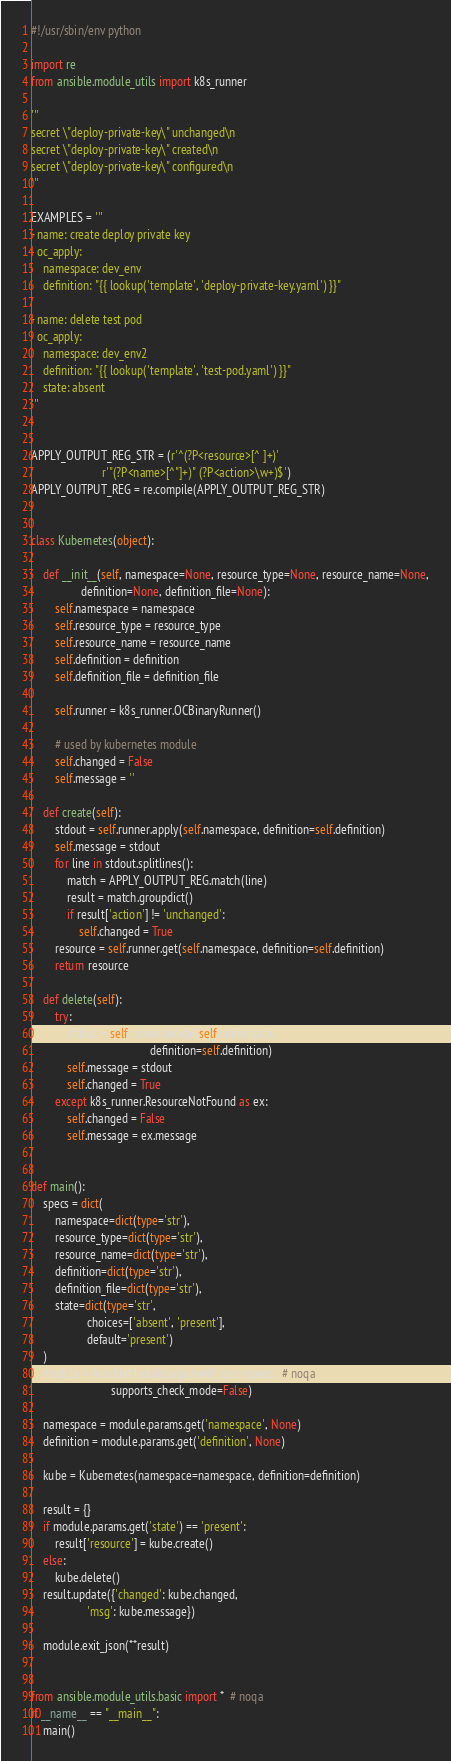Convert code to text. <code><loc_0><loc_0><loc_500><loc_500><_Python_>#!/usr/sbin/env python

import re
from ansible.module_utils import k8s_runner

'''
secret \"deploy-private-key\" unchanged\n
secret \"deploy-private-key\" created\n
secret \"deploy-private-key\" configured\n
'''

EXAMPLES = '''
- name: create deploy private key
  oc_apply:
    namespace: dev_env
    definition: "{{ lookup('template', 'deploy-private-key.yaml') }}"

- name: delete test pod
  oc_apply:
    namespace: dev_env2
    definition: "{{ lookup('template', 'test-pod.yaml') }}"
    state: absent
'''


APPLY_OUTPUT_REG_STR = (r'^(?P<resource>[^ ]+)'
                        r'"(?P<name>[^"]+)" (?P<action>\w+)$')
APPLY_OUTPUT_REG = re.compile(APPLY_OUTPUT_REG_STR)


class Kubernetes(object):

    def __init__(self, namespace=None, resource_type=None, resource_name=None,
                 definition=None, definition_file=None):
        self.namespace = namespace
        self.resource_type = resource_type
        self.resource_name = resource_name
        self.definition = definition
        self.definition_file = definition_file

        self.runner = k8s_runner.OCBinaryRunner()

        # used by kubernetes module
        self.changed = False
        self.message = ''

    def create(self):
        stdout = self.runner.apply(self.namespace, definition=self.definition)
        self.message = stdout
        for line in stdout.splitlines():
            match = APPLY_OUTPUT_REG.match(line)
            result = match.groupdict()
            if result['action'] != 'unchanged':
                self.changed = True
        resource = self.runner.get(self.namespace, definition=self.definition)
        return resource

    def delete(self):
        try:
            stdout = self.runner.delete(self.namespace,
                                        definition=self.definition)
            self.message = stdout
            self.changed = True
        except k8s_runner.ResourceNotFound as ex:
            self.changed = False
            self.message = ex.message


def main():
    specs = dict(
        namespace=dict(type='str'),
        resource_type=dict(type='str'),
        resource_name=dict(type='str'),
        definition=dict(type='str'),
        definition_file=dict(type='str'),
        state=dict(type='str',
                   choices=['absent', 'present'],
                   default='present')
    )
    module = AnsibleModule(argument_spec=specs,  # noqa
                           supports_check_mode=False)

    namespace = module.params.get('namespace', None)
    definition = module.params.get('definition', None)

    kube = Kubernetes(namespace=namespace, definition=definition)

    result = {}
    if module.params.get('state') == 'present':
        result['resource'] = kube.create()
    else:
        kube.delete()
    result.update({'changed': kube.changed,
                   'msg': kube.message})

    module.exit_json(**result)


from ansible.module_utils.basic import *  # noqa
if __name__ == "__main__":
    main()
</code> 